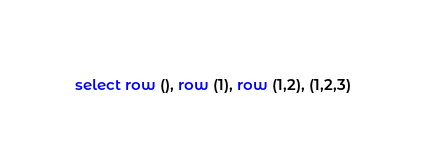<code> <loc_0><loc_0><loc_500><loc_500><_SQL_>select row (), row (1), row (1,2), (1,2,3)
</code> 